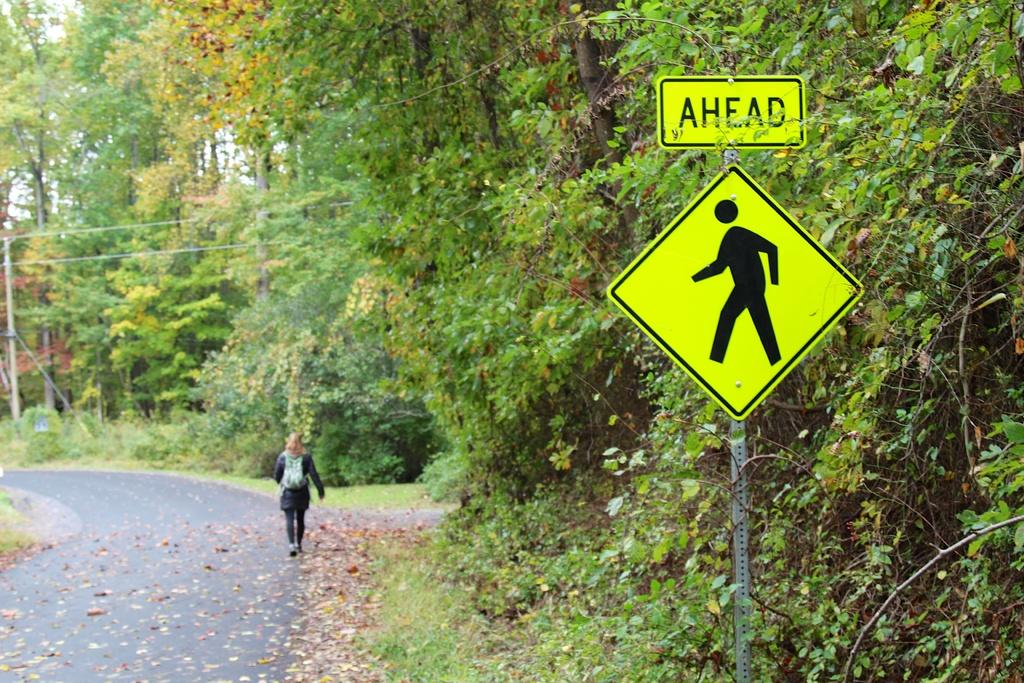<image>
Summarize the visual content of the image. A lady is walking down a road and away from a sign that shows pedestrians Ahead. 